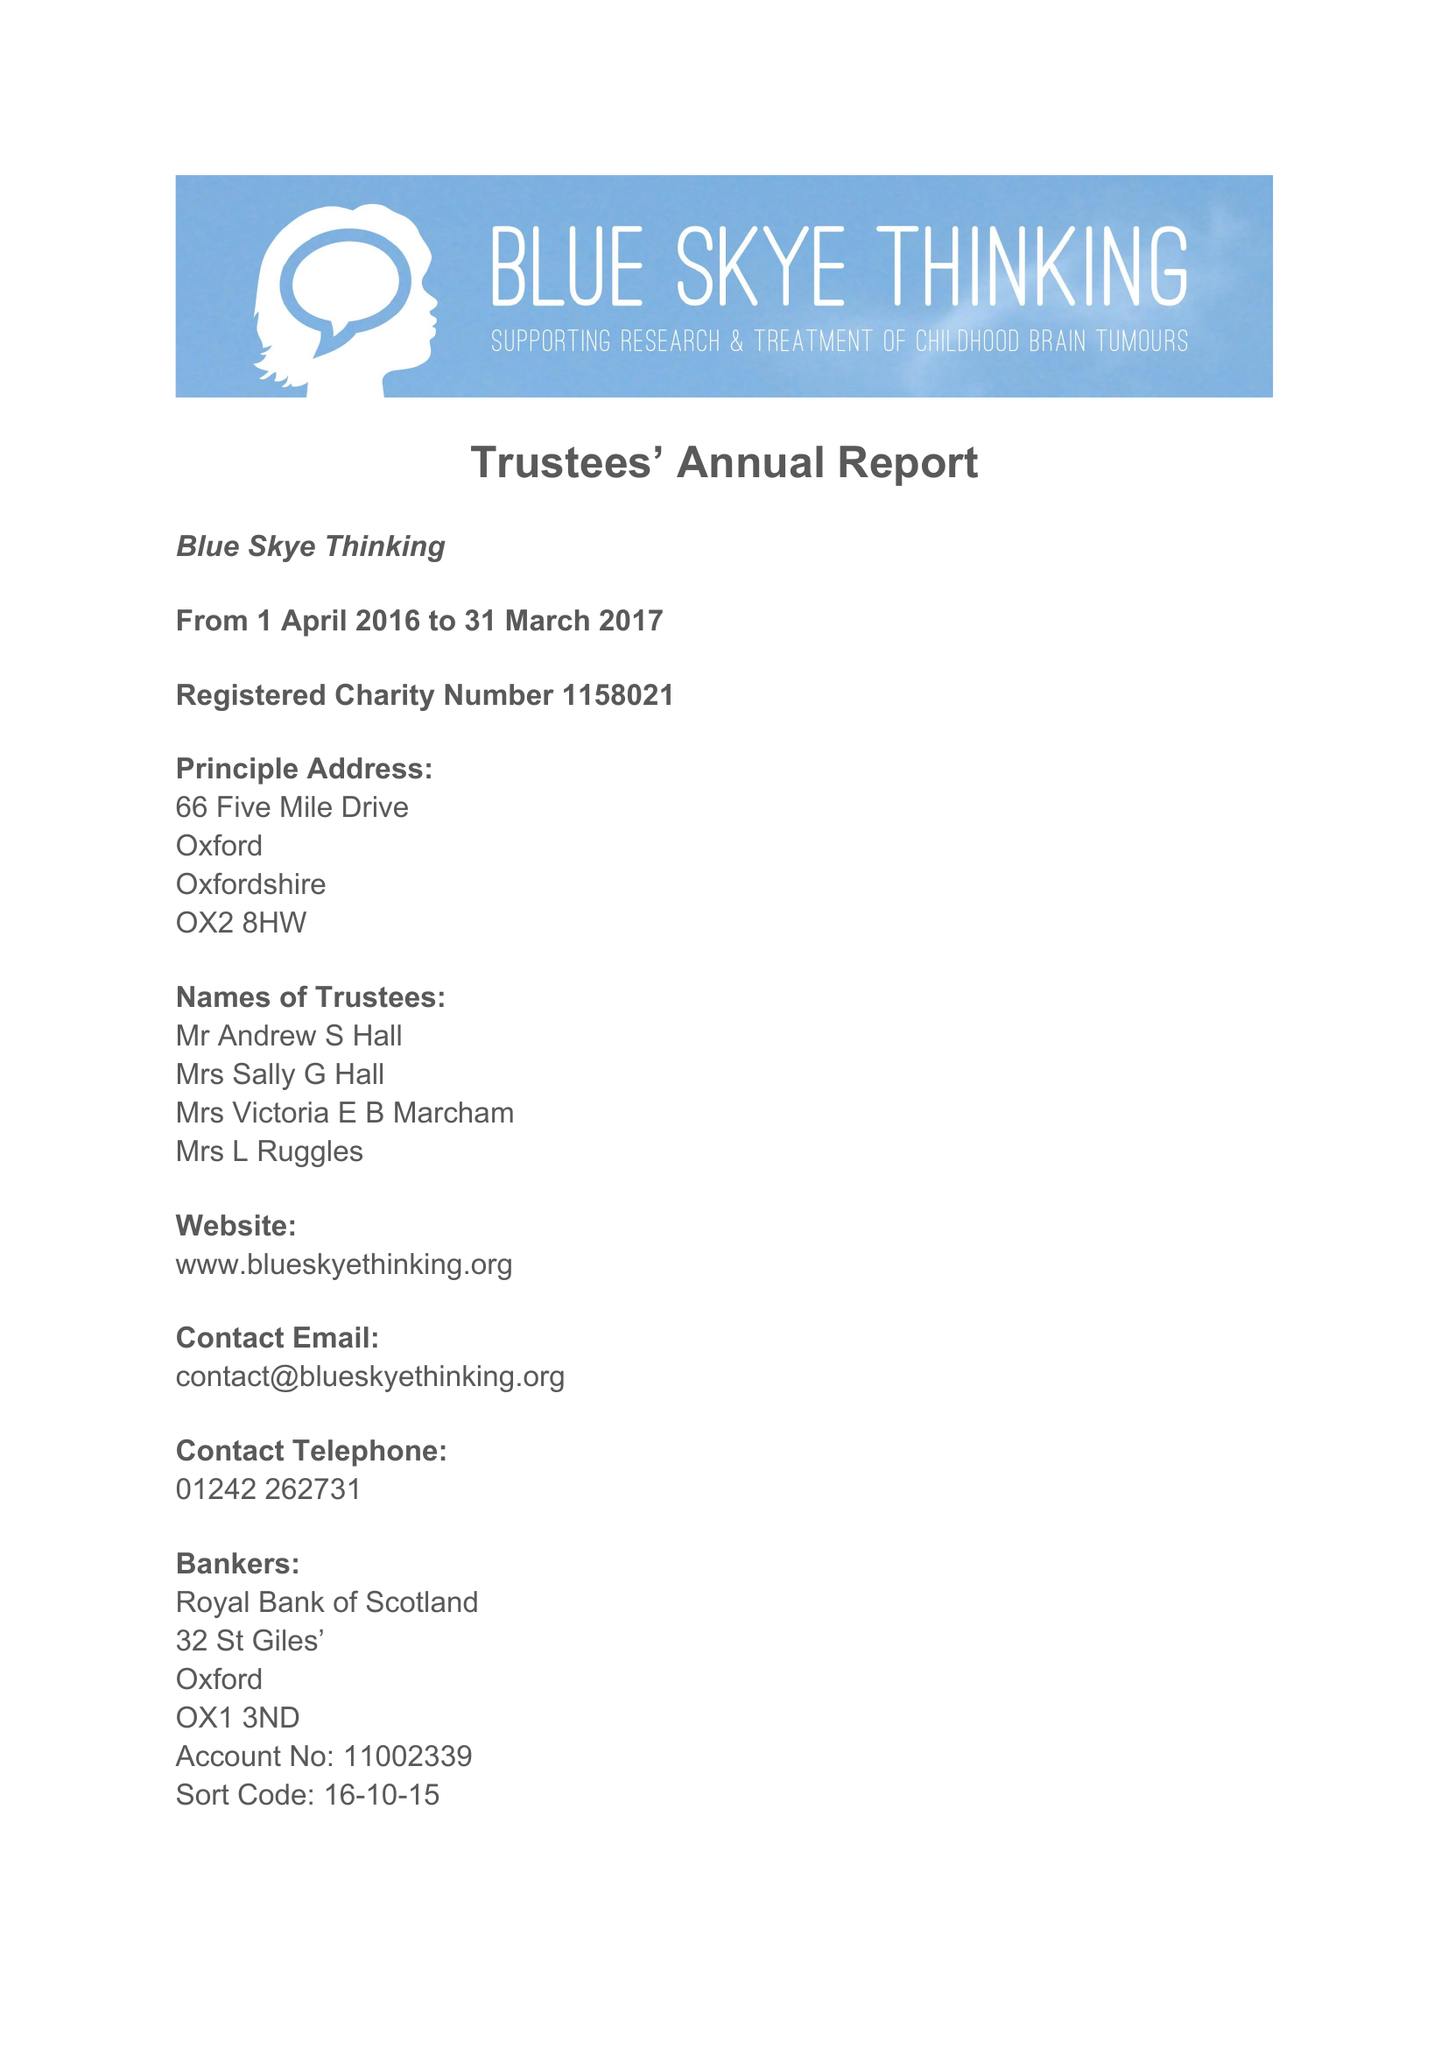What is the value for the spending_annually_in_british_pounds?
Answer the question using a single word or phrase. 56058.00 